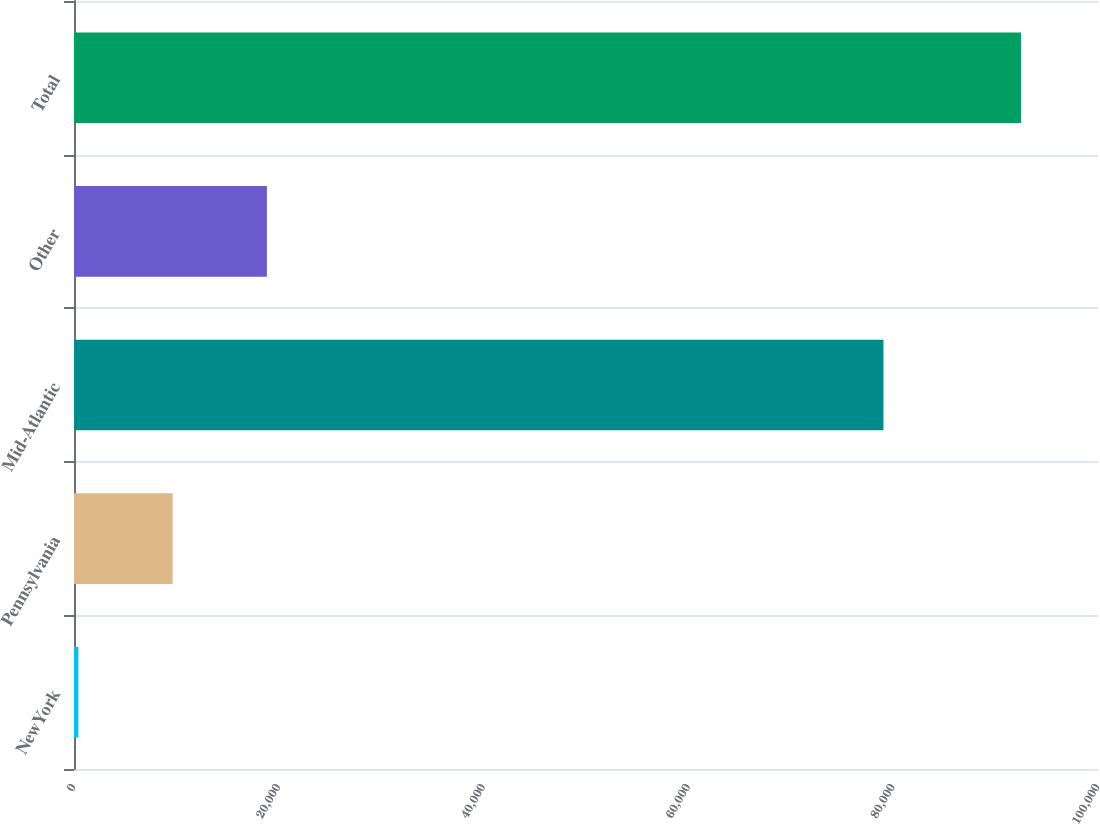Convert chart to OTSL. <chart><loc_0><loc_0><loc_500><loc_500><bar_chart><fcel>NewYork<fcel>Pennsylvania<fcel>Mid-Atlantic<fcel>Other<fcel>Total<nl><fcel>427<fcel>9632.1<fcel>79047<fcel>18837.2<fcel>92478<nl></chart> 